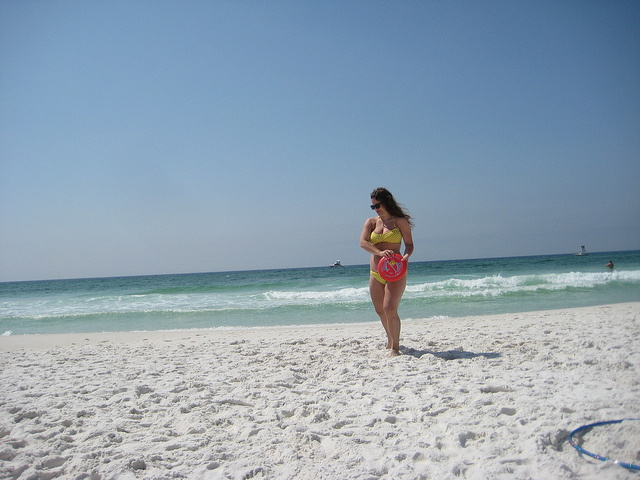How many people are walking on the beach? 1 